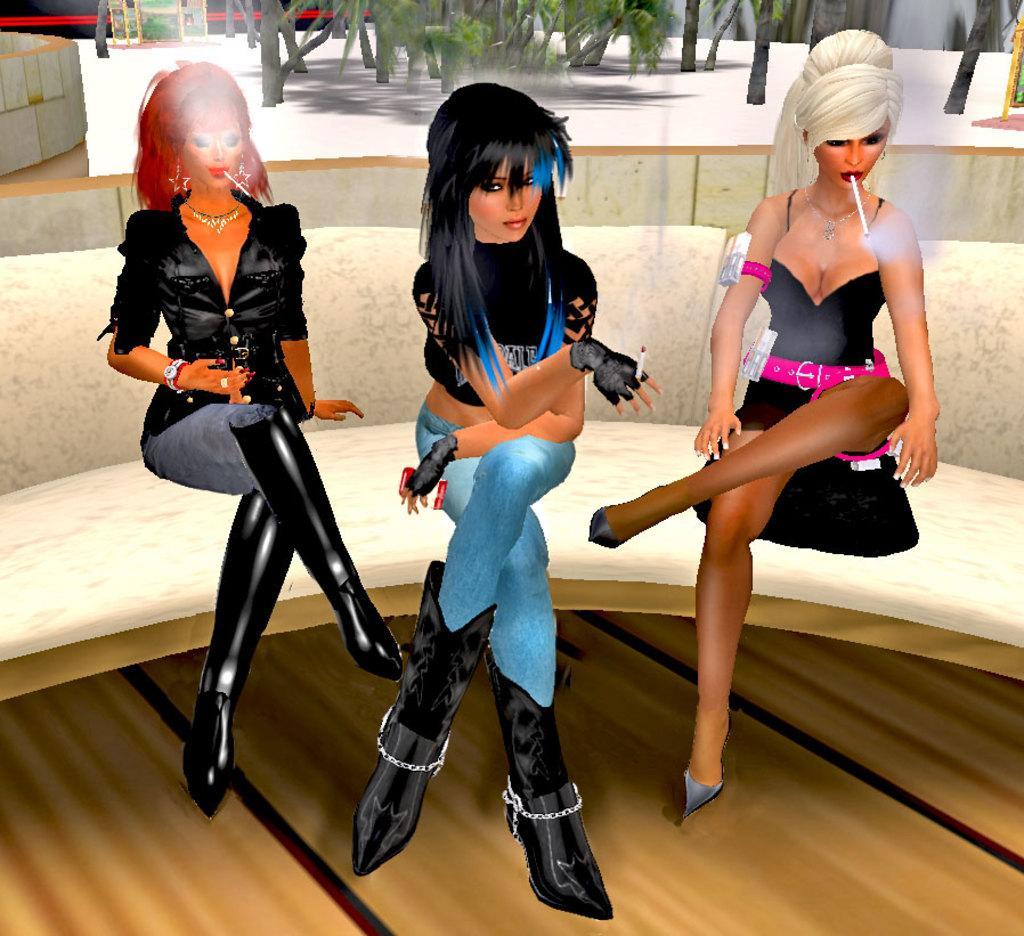Could you give a brief overview of what you see in this image? This image is animated. In the front, we can see three women sitting in a sofa. In the background, we can see the trees. 